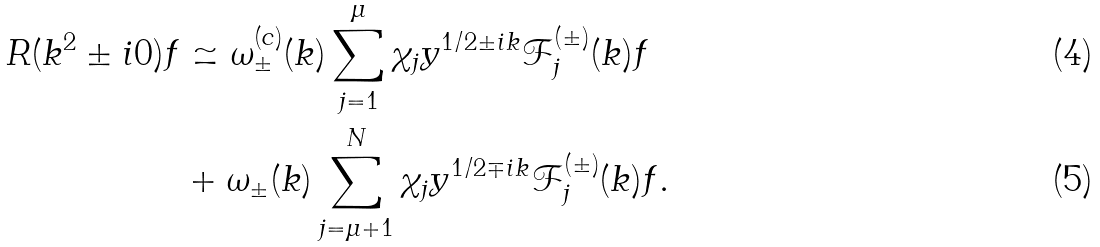<formula> <loc_0><loc_0><loc_500><loc_500>R ( k ^ { 2 } \pm i 0 ) f & \simeq \omega _ { \pm } ^ { ( c ) } ( k ) \sum _ { j = 1 } ^ { \mu } \chi _ { j } y ^ { 1 / 2 \pm i k } { \mathcal { F } } ^ { ( \pm ) } _ { j } ( k ) f \\ & + \omega _ { \pm } ( k ) \sum _ { j = \mu + 1 } ^ { N } \chi _ { j } y ^ { 1 / 2 \mp i k } { \mathcal { F } } ^ { ( \pm ) } _ { j } ( k ) f .</formula> 